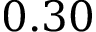<formula> <loc_0><loc_0><loc_500><loc_500>0 . 3 0</formula> 